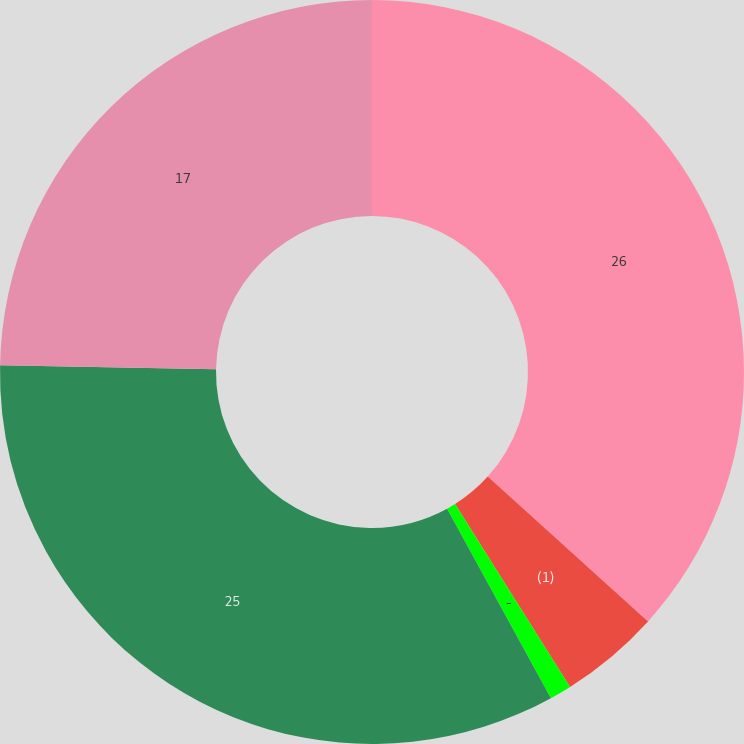Convert chart. <chart><loc_0><loc_0><loc_500><loc_500><pie_chart><fcel>26<fcel>(1)<fcel>-<fcel>25<fcel>17<nl><fcel>36.69%<fcel>4.37%<fcel>0.95%<fcel>33.27%<fcel>24.71%<nl></chart> 